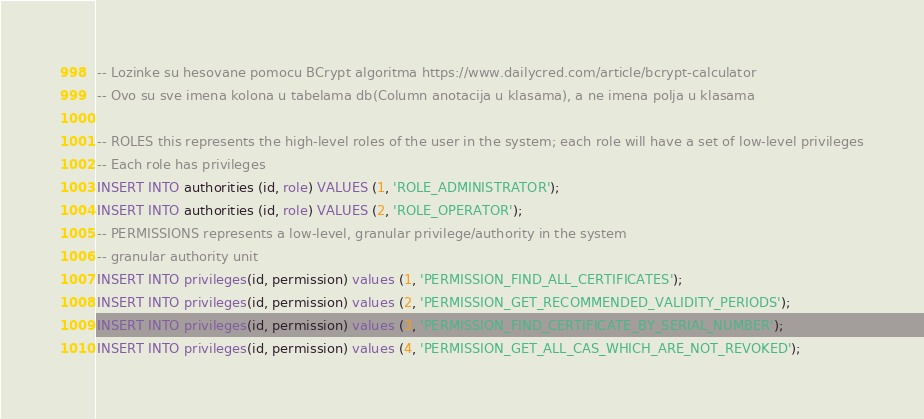<code> <loc_0><loc_0><loc_500><loc_500><_SQL_>-- Lozinke su hesovane pomocu BCrypt algoritma https://www.dailycred.com/article/bcrypt-calculator
-- Ovo su sve imena kolona u tabelama db(Column anotacija u klasama), a ne imena polja u klasama

-- ROLES this represents the high-level roles of the user in the system; each role will have a set of low-level privileges
-- Each role has privileges
INSERT INTO authorities (id, role) VALUES (1, 'ROLE_ADMINISTRATOR');
INSERT INTO authorities (id, role) VALUES (2, 'ROLE_OPERATOR');
-- PERMISSIONS represents a low-level, granular privilege/authority in the system
-- granular authority unit
INSERT INTO privileges(id, permission) values (1, 'PERMISSION_FIND_ALL_CERTIFICATES');
INSERT INTO privileges(id, permission) values (2, 'PERMISSION_GET_RECOMMENDED_VALIDITY_PERIODS');
INSERT INTO privileges(id, permission) values (3, 'PERMISSION_FIND_CERTIFICATE_BY_SERIAL_NUMBER');
INSERT INTO privileges(id, permission) values (4, 'PERMISSION_GET_ALL_CAS_WHICH_ARE_NOT_REVOKED');</code> 